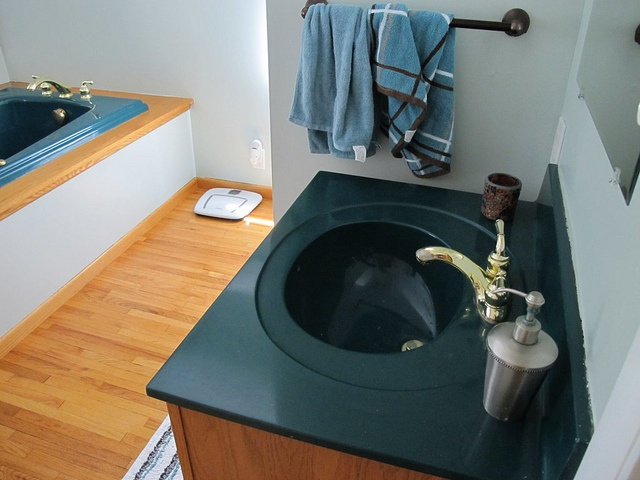Describe the objects in this image and their specific colors. I can see sink in darkgray, black, purple, and teal tones, bottle in darkgray, black, and gray tones, and cup in darkgray, black, and gray tones in this image. 